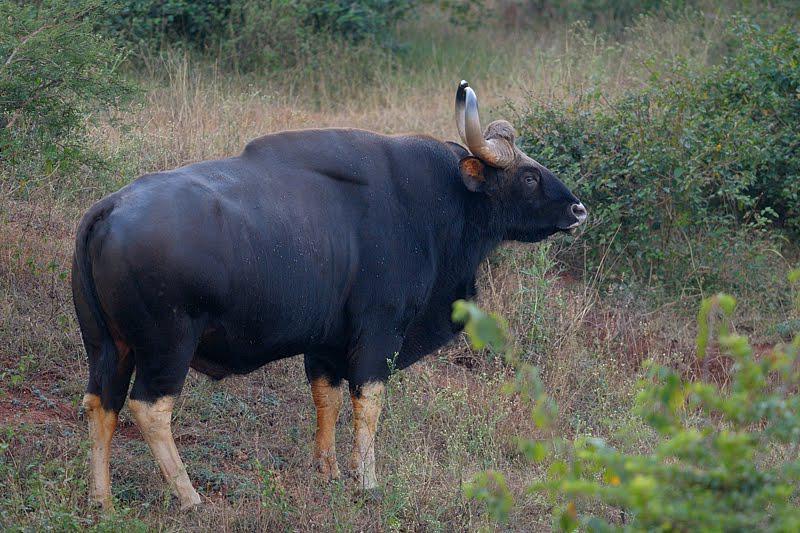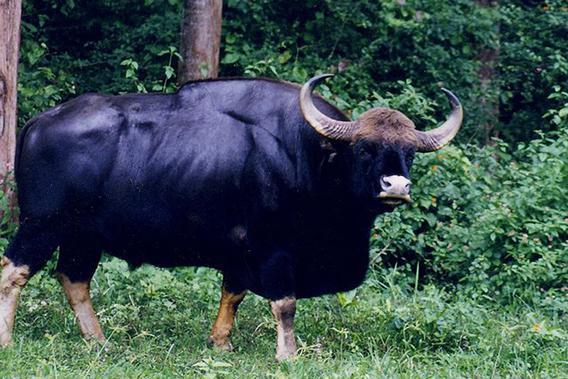The first image is the image on the left, the second image is the image on the right. Considering the images on both sides, is "Each image contains exactly one horned animal, and the horned animal in the right image has its face turned to the camera." valid? Answer yes or no. Yes. 